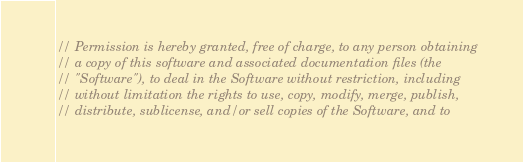<code> <loc_0><loc_0><loc_500><loc_500><_C#_>// Permission is hereby granted, free of charge, to any person obtaining
// a copy of this software and associated documentation files (the
// "Software"), to deal in the Software without restriction, including
// without limitation the rights to use, copy, modify, merge, publish,
// distribute, sublicense, and/or sell copies of the Software, and to</code> 